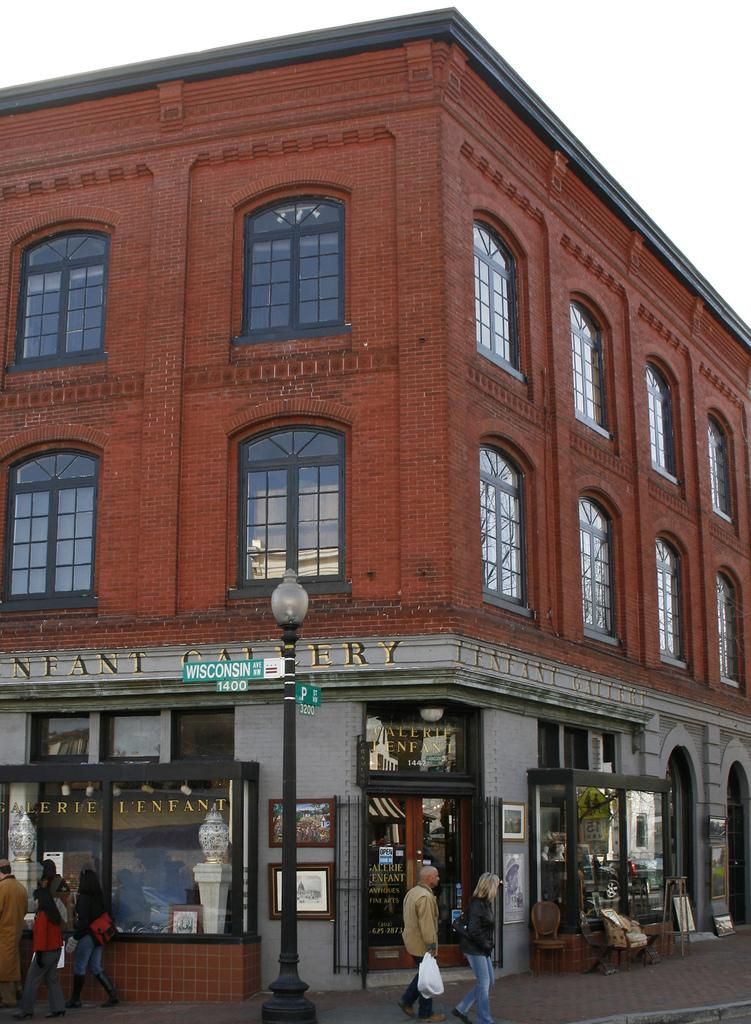What type of structure is visible in the image? There is a building in the image. What are the people in the image doing? People are walking on the pavement in front of the building. What object can be seen in the image besides the building and people? There is a pole in the image. What is the color of the sky in the image? The sky is white in color at the top of the image. What type of paper is being discussed in the meeting taking place inside the building? There is no indication of a meeting taking place inside the building, nor is there any paper mentioned in the image. 